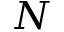<formula> <loc_0><loc_0><loc_500><loc_500>N</formula> 